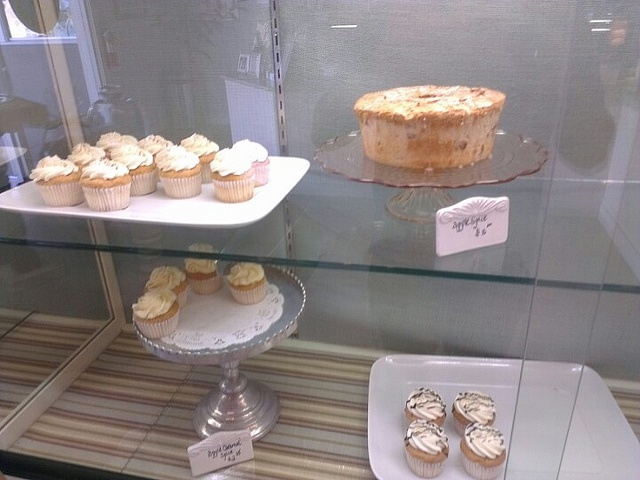Describe the objects in this image and their specific colors. I can see cake in gray, tan, and beige tones, cake in gray, lightgray, darkgray, and tan tones, cake in gray, lightgray, and tan tones, cake in gray, tan, ivory, and darkgray tones, and cake in gray, white, and tan tones in this image. 